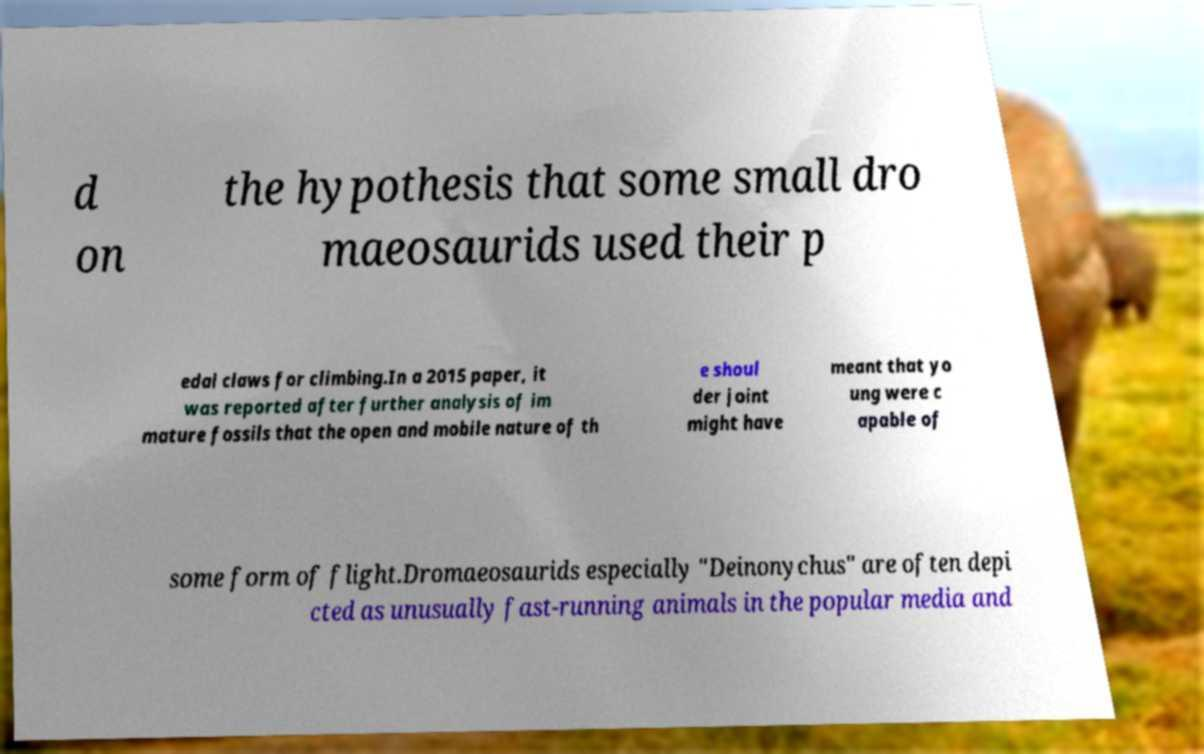There's text embedded in this image that I need extracted. Can you transcribe it verbatim? d on the hypothesis that some small dro maeosaurids used their p edal claws for climbing.In a 2015 paper, it was reported after further analysis of im mature fossils that the open and mobile nature of th e shoul der joint might have meant that yo ung were c apable of some form of flight.Dromaeosaurids especially "Deinonychus" are often depi cted as unusually fast-running animals in the popular media and 